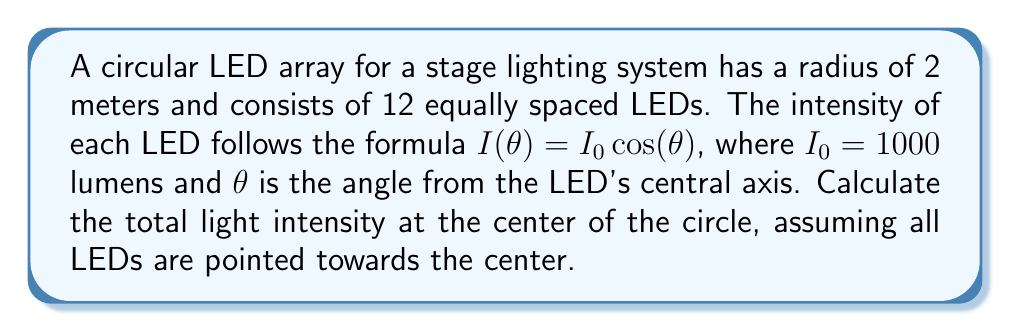Help me with this question. To solve this problem, we need to follow these steps:

1. Determine the angle between each LED in the circular array:
   $$\text{Angle between LEDs} = \frac{360°}{12} = 30°$$

2. Calculate the angle $\theta$ for each LED relative to the center:
   Since the LEDs are pointed towards the center, $\theta = 0°$ for all LEDs.

3. Calculate the intensity contribution from each LED:
   $$I(\theta) = I_0 \cos(\theta) = 1000 \cos(0°) = 1000 \text{ lumens}$$

4. Sum the contributions from all 12 LEDs:
   $$\text{Total Intensity} = 12 \times 1000 = 12000 \text{ lumens}$$

Note: In this case, we didn't need to use polar coordinates explicitly because all LEDs contribute equally due to their orientation. However, if the LEDs were angled differently, we would need to consider their individual angles and use the polar coordinate system to calculate their contributions.

[asy]
unitsize(50);
draw(circle((0,0),2));
for(int i=0; i<12; ++i) {
  real angle = i*pi/6;
  dot((2*cos(angle), 2*sin(angle)));
  draw((2*cos(angle), 2*sin(angle))--(0,0),arrow=Arrow(SimpleHead));
}
label("Center", (0,0), S);
[/asy]
Answer: The total light intensity at the center of the circular LED array is 12000 lumens. 